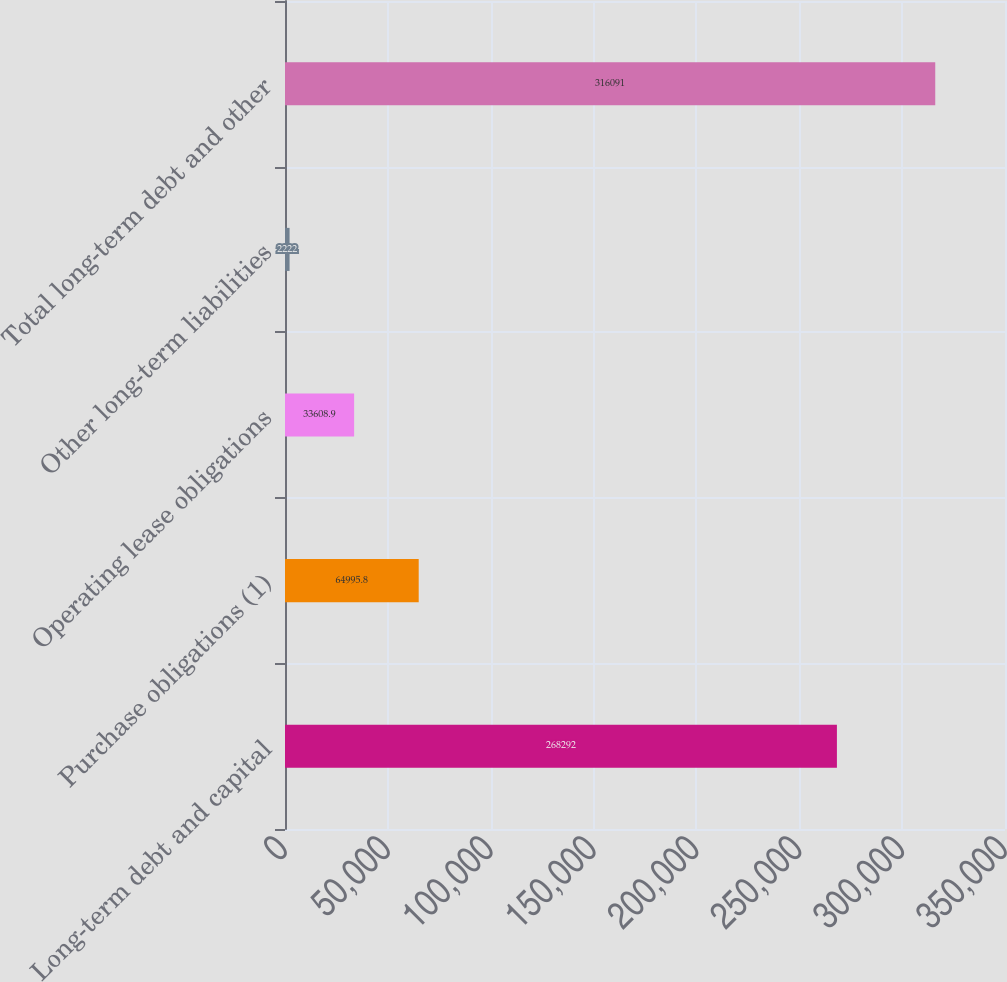<chart> <loc_0><loc_0><loc_500><loc_500><bar_chart><fcel>Long-term debt and capital<fcel>Purchase obligations (1)<fcel>Operating lease obligations<fcel>Other long-term liabilities<fcel>Total long-term debt and other<nl><fcel>268292<fcel>64995.8<fcel>33608.9<fcel>2222<fcel>316091<nl></chart> 